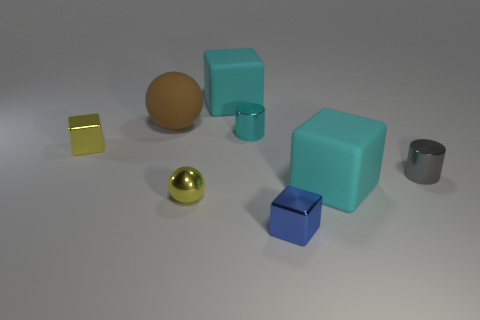Subtract 1 cubes. How many cubes are left? 3 Add 1 cyan rubber objects. How many objects exist? 9 Subtract all cylinders. How many objects are left? 6 Add 3 large cyan matte spheres. How many large cyan matte spheres exist? 3 Subtract 0 cyan spheres. How many objects are left? 8 Subtract all tiny cubes. Subtract all yellow metal balls. How many objects are left? 5 Add 8 blue blocks. How many blue blocks are left? 9 